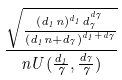<formula> <loc_0><loc_0><loc_500><loc_500>\frac { \sqrt { \frac { ( d _ { 1 } n ) ^ { d _ { 1 } } d _ { 7 } ^ { d _ { 7 } } } { ( d _ { 1 } n + d _ { 7 } ) ^ { d _ { 1 } + d _ { 7 } } } } } { n U ( \frac { d _ { 1 } } { 7 } , \frac { d _ { 7 } } { 7 } ) }</formula> 